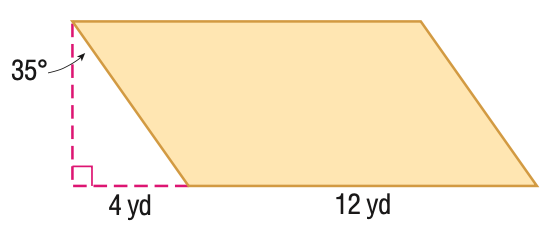Answer the mathemtical geometry problem and directly provide the correct option letter.
Question: Find the area of the figure. Round to the nearest hundredth, if necessary.
Choices: A: 33.6 B: 48 C: 58.6 D: 68.6 D 